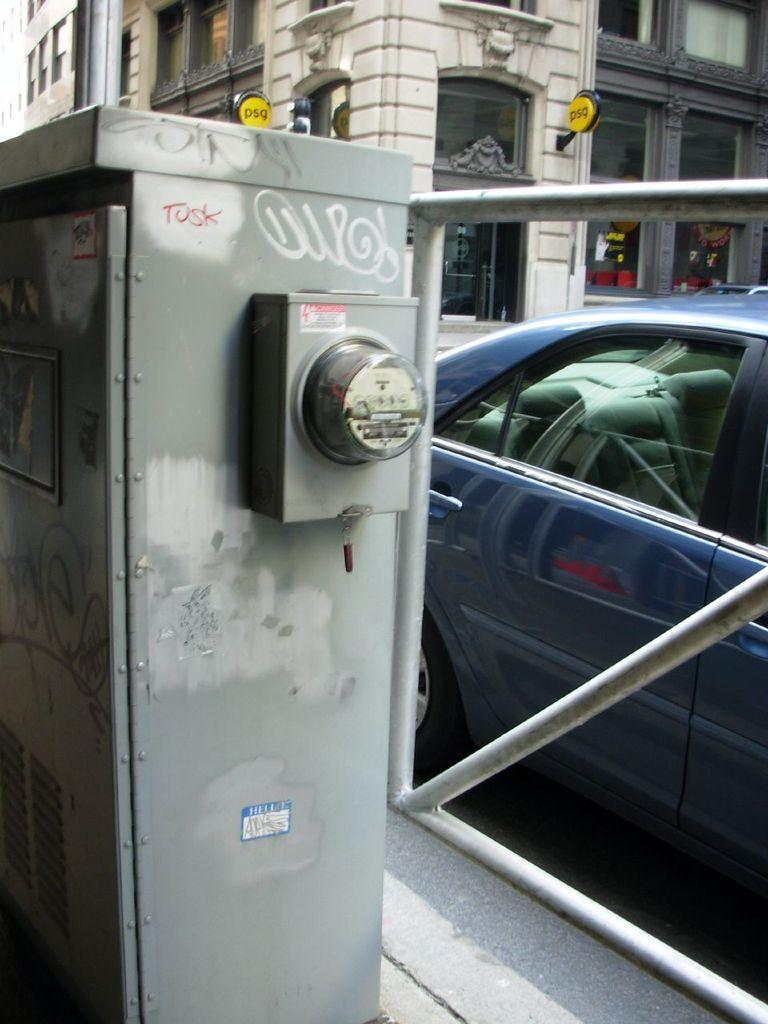What object can be seen in the image that is typically used for storing items? There is an iron box in the image. What structure is visible in the image that separates areas or provides a boundary? There is a fence in the image. What mode of transportation can be seen on the road in the image? There is a car on the road in the image. What type of structure is located opposite the car in the image? There is a building opposite the car in the image. Can you describe the heated discussion taking place between the car and the building in the image? There is no discussion or interaction between the car and the building in the image; they are simply objects located in the scene. 